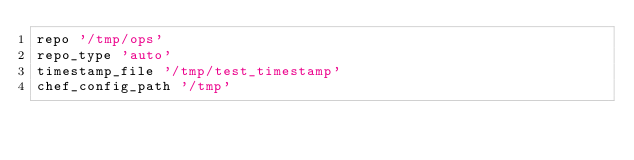<code> <loc_0><loc_0><loc_500><loc_500><_Ruby_>repo '/tmp/ops'
repo_type 'auto'
timestamp_file '/tmp/test_timestamp'
chef_config_path '/tmp'
</code> 